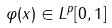<formula> <loc_0><loc_0><loc_500><loc_500>\varphi ( x ) \in L ^ { p } [ 0 , 1 ]</formula> 